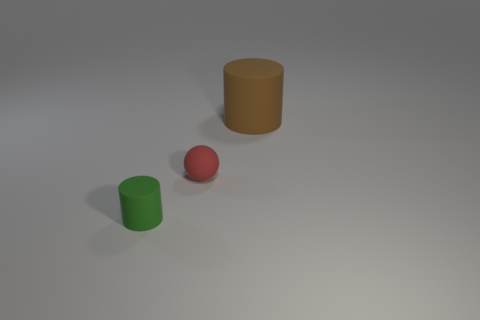Add 1 tiny balls. How many objects exist? 4 Subtract all cylinders. How many objects are left? 1 Subtract all spheres. Subtract all tiny green objects. How many objects are left? 1 Add 3 brown matte cylinders. How many brown matte cylinders are left? 4 Add 1 tiny rubber things. How many tiny rubber things exist? 3 Subtract 0 cyan blocks. How many objects are left? 3 Subtract all cyan spheres. Subtract all blue cylinders. How many spheres are left? 1 